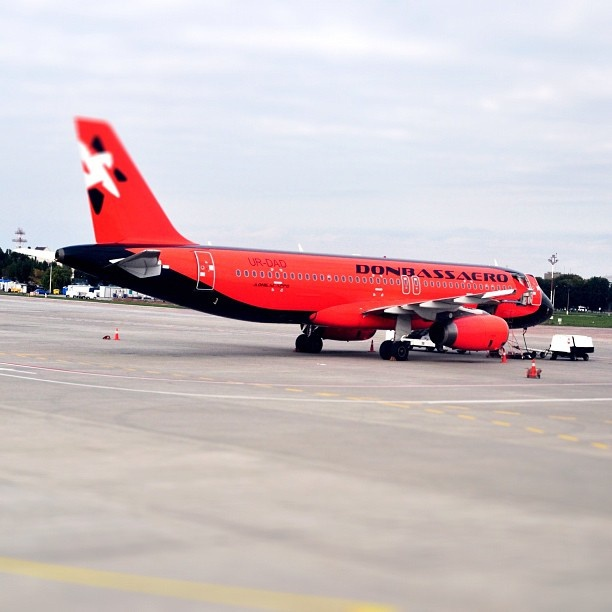Describe the objects in this image and their specific colors. I can see airplane in lavender, red, black, salmon, and white tones and truck in lavender, white, black, gray, and darkgray tones in this image. 